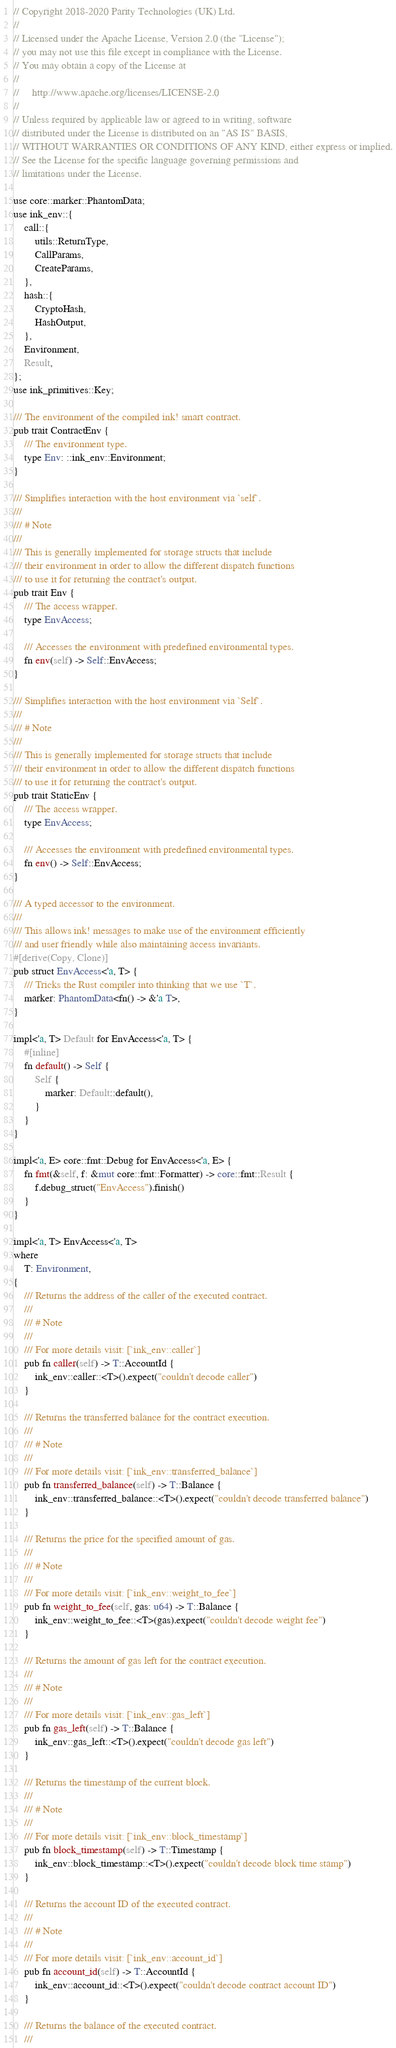<code> <loc_0><loc_0><loc_500><loc_500><_Rust_>// Copyright 2018-2020 Parity Technologies (UK) Ltd.
//
// Licensed under the Apache License, Version 2.0 (the "License");
// you may not use this file except in compliance with the License.
// You may obtain a copy of the License at
//
//     http://www.apache.org/licenses/LICENSE-2.0
//
// Unless required by applicable law or agreed to in writing, software
// distributed under the License is distributed on an "AS IS" BASIS,
// WITHOUT WARRANTIES OR CONDITIONS OF ANY KIND, either express or implied.
// See the License for the specific language governing permissions and
// limitations under the License.

use core::marker::PhantomData;
use ink_env::{
    call::{
        utils::ReturnType,
        CallParams,
        CreateParams,
    },
    hash::{
        CryptoHash,
        HashOutput,
    },
    Environment,
    Result,
};
use ink_primitives::Key;

/// The environment of the compiled ink! smart contract.
pub trait ContractEnv {
    /// The environment type.
    type Env: ::ink_env::Environment;
}

/// Simplifies interaction with the host environment via `self`.
///
/// # Note
///
/// This is generally implemented for storage structs that include
/// their environment in order to allow the different dispatch functions
/// to use it for returning the contract's output.
pub trait Env {
    /// The access wrapper.
    type EnvAccess;

    /// Accesses the environment with predefined environmental types.
    fn env(self) -> Self::EnvAccess;
}

/// Simplifies interaction with the host environment via `Self`.
///
/// # Note
///
/// This is generally implemented for storage structs that include
/// their environment in order to allow the different dispatch functions
/// to use it for returning the contract's output.
pub trait StaticEnv {
    /// The access wrapper.
    type EnvAccess;

    /// Accesses the environment with predefined environmental types.
    fn env() -> Self::EnvAccess;
}

/// A typed accessor to the environment.
///
/// This allows ink! messages to make use of the environment efficiently
/// and user friendly while also maintaining access invariants.
#[derive(Copy, Clone)]
pub struct EnvAccess<'a, T> {
    /// Tricks the Rust compiler into thinking that we use `T`.
    marker: PhantomData<fn() -> &'a T>,
}

impl<'a, T> Default for EnvAccess<'a, T> {
    #[inline]
    fn default() -> Self {
        Self {
            marker: Default::default(),
        }
    }
}

impl<'a, E> core::fmt::Debug for EnvAccess<'a, E> {
    fn fmt(&self, f: &mut core::fmt::Formatter) -> core::fmt::Result {
        f.debug_struct("EnvAccess").finish()
    }
}

impl<'a, T> EnvAccess<'a, T>
where
    T: Environment,
{
    /// Returns the address of the caller of the executed contract.
    ///
    /// # Note
    ///
    /// For more details visit: [`ink_env::caller`]
    pub fn caller(self) -> T::AccountId {
        ink_env::caller::<T>().expect("couldn't decode caller")
    }

    /// Returns the transferred balance for the contract execution.
    ///
    /// # Note
    ///
    /// For more details visit: [`ink_env::transferred_balance`]
    pub fn transferred_balance(self) -> T::Balance {
        ink_env::transferred_balance::<T>().expect("couldn't decode transferred balance")
    }

    /// Returns the price for the specified amount of gas.
    ///
    /// # Note
    ///
    /// For more details visit: [`ink_env::weight_to_fee`]
    pub fn weight_to_fee(self, gas: u64) -> T::Balance {
        ink_env::weight_to_fee::<T>(gas).expect("couldn't decode weight fee")
    }

    /// Returns the amount of gas left for the contract execution.
    ///
    /// # Note
    ///
    /// For more details visit: [`ink_env::gas_left`]
    pub fn gas_left(self) -> T::Balance {
        ink_env::gas_left::<T>().expect("couldn't decode gas left")
    }

    /// Returns the timestamp of the current block.
    ///
    /// # Note
    ///
    /// For more details visit: [`ink_env::block_timestamp`]
    pub fn block_timestamp(self) -> T::Timestamp {
        ink_env::block_timestamp::<T>().expect("couldn't decode block time stamp")
    }

    /// Returns the account ID of the executed contract.
    ///
    /// # Note
    ///
    /// For more details visit: [`ink_env::account_id`]
    pub fn account_id(self) -> T::AccountId {
        ink_env::account_id::<T>().expect("couldn't decode contract account ID")
    }

    /// Returns the balance of the executed contract.
    ///</code> 